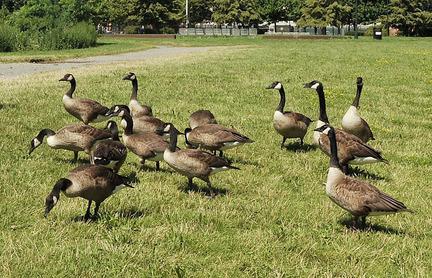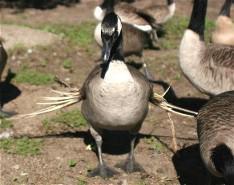The first image is the image on the left, the second image is the image on the right. Assess this claim about the two images: "The right image contains no more than one goose.". Correct or not? Answer yes or no. No. The first image is the image on the left, the second image is the image on the right. For the images shown, is this caption "No image contains more than two geese, and all geese are standing in grassy areas." true? Answer yes or no. No. 